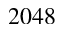Convert formula to latex. <formula><loc_0><loc_0><loc_500><loc_500>2 0 4 8</formula> 